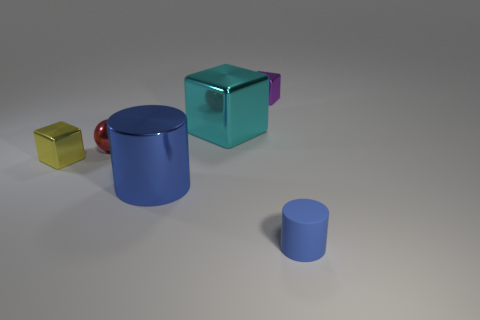Subtract all purple cubes. How many cubes are left? 2 Add 1 red spheres. How many objects exist? 7 Subtract all balls. How many objects are left? 5 Subtract all purple spheres. Subtract all purple cubes. How many spheres are left? 1 Subtract all big brown metal spheres. Subtract all purple metallic cubes. How many objects are left? 5 Add 4 large cyan blocks. How many large cyan blocks are left? 5 Add 6 tiny gray metallic objects. How many tiny gray metallic objects exist? 6 Subtract 0 purple balls. How many objects are left? 6 Subtract 1 spheres. How many spheres are left? 0 